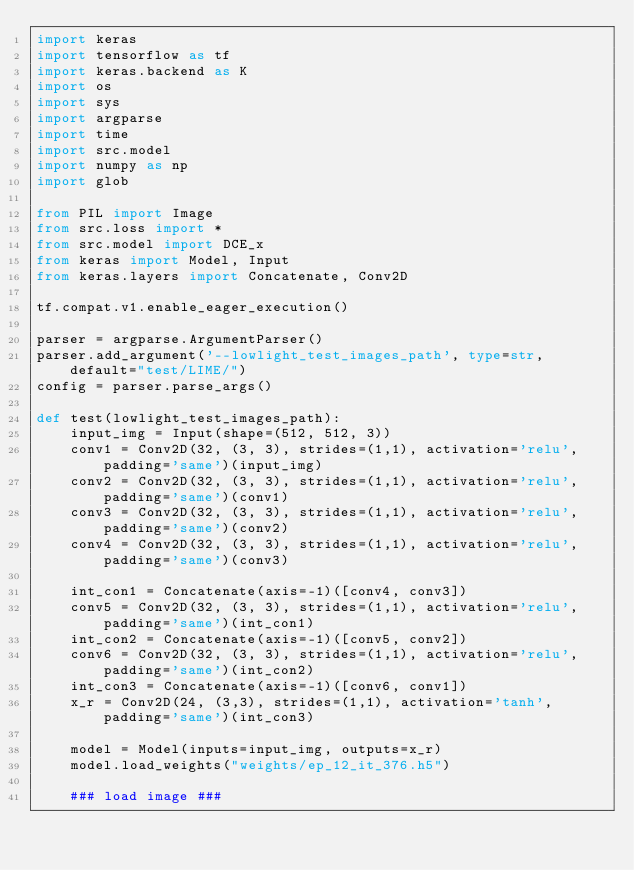<code> <loc_0><loc_0><loc_500><loc_500><_Python_>import keras
import tensorflow as tf
import keras.backend as K
import os
import sys
import argparse
import time
import src.model
import numpy as np
import glob

from PIL import Image
from src.loss import *
from src.model import DCE_x
from keras import Model, Input
from keras.layers import Concatenate, Conv2D

tf.compat.v1.enable_eager_execution()

parser = argparse.ArgumentParser()
parser.add_argument('--lowlight_test_images_path', type=str, default="test/LIME/")
config = parser.parse_args()

def test(lowlight_test_images_path):
    input_img = Input(shape=(512, 512, 3))
    conv1 = Conv2D(32, (3, 3), strides=(1,1), activation='relu', padding='same')(input_img)
    conv2 = Conv2D(32, (3, 3), strides=(1,1), activation='relu', padding='same')(conv1)
    conv3 = Conv2D(32, (3, 3), strides=(1,1), activation='relu', padding='same')(conv2)
    conv4 = Conv2D(32, (3, 3), strides=(1,1), activation='relu', padding='same')(conv3)

    int_con1 = Concatenate(axis=-1)([conv4, conv3])
    conv5 = Conv2D(32, (3, 3), strides=(1,1), activation='relu', padding='same')(int_con1)
    int_con2 = Concatenate(axis=-1)([conv5, conv2])
    conv6 = Conv2D(32, (3, 3), strides=(1,1), activation='relu', padding='same')(int_con2)
    int_con3 = Concatenate(axis=-1)([conv6, conv1])
    x_r = Conv2D(24, (3,3), strides=(1,1), activation='tanh', padding='same')(int_con3)

    model = Model(inputs=input_img, outputs=x_r)
    model.load_weights("weights/ep_12_it_376.h5")

    ### load image ###</code> 